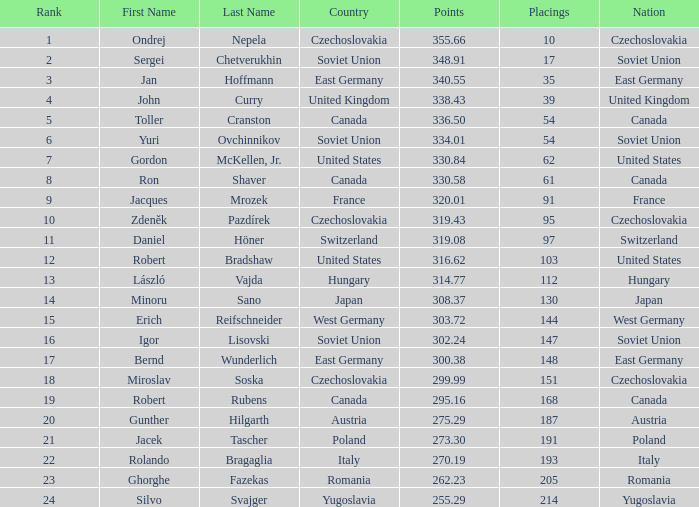Which country has a score of 300.38? East Germany. 